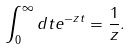Convert formula to latex. <formula><loc_0><loc_0><loc_500><loc_500>\int _ { 0 } ^ { \infty } d t e ^ { - z t } = \frac { 1 } { z } .</formula> 